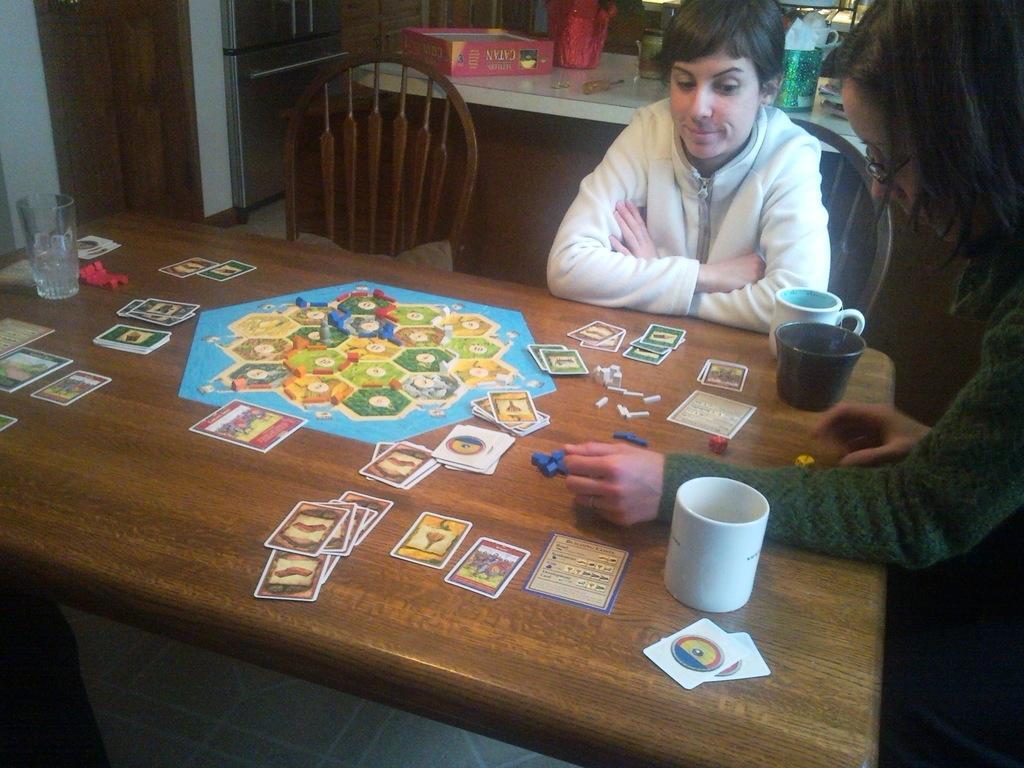How would you summarize this image in a sentence or two? In this picture we can see two persons are seated on the chair, in front of them we can see cups, cards and a glass on the table. In the background we can find a flower vase, box and some tools on the table. 